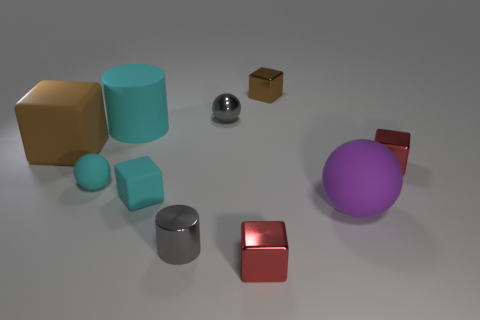Subtract all cyan blocks. How many blocks are left? 4 Subtract all tiny cyan rubber cubes. How many cubes are left? 4 Subtract all blue cylinders. Subtract all yellow blocks. How many cylinders are left? 2 Subtract all cylinders. How many objects are left? 8 Add 6 cyan rubber blocks. How many cyan rubber blocks are left? 7 Add 5 small rubber objects. How many small rubber objects exist? 7 Subtract 2 red blocks. How many objects are left? 8 Subtract all cylinders. Subtract all big blue shiny cubes. How many objects are left? 8 